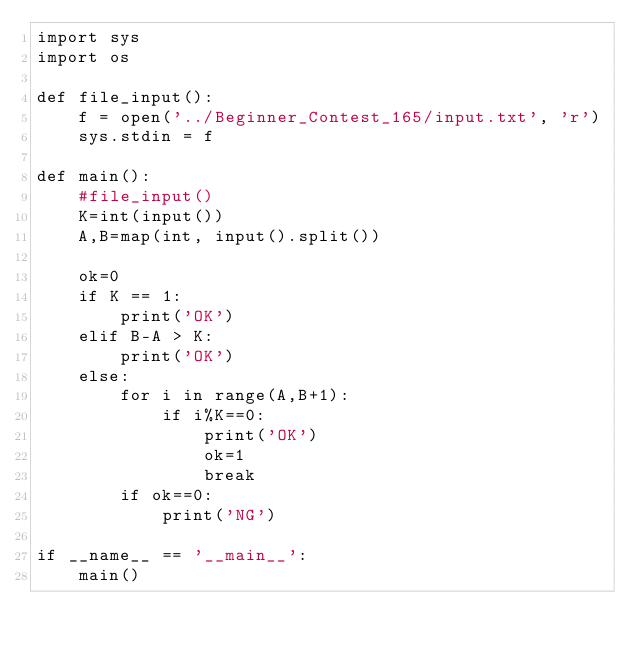Convert code to text. <code><loc_0><loc_0><loc_500><loc_500><_Python_>import sys
import os

def file_input():
    f = open('../Beginner_Contest_165/input.txt', 'r')
    sys.stdin = f

def main():
    #file_input()
    K=int(input())
    A,B=map(int, input().split())

    ok=0
    if K == 1:
        print('OK')
    elif B-A > K:
        print('OK')
    else:
        for i in range(A,B+1):
            if i%K==0:
                print('OK')
                ok=1
                break
        if ok==0:
            print('NG')

if __name__ == '__main__':
    main()
</code> 